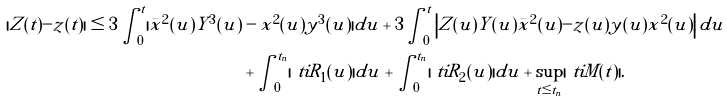Convert formula to latex. <formula><loc_0><loc_0><loc_500><loc_500>| Z ( t ) - z ( t ) | \leq 3 \int _ { 0 } ^ { t } | \bar { x } ^ { 2 } ( u ) Y ^ { 3 } ( u ) & - x ^ { 2 } ( u ) y ^ { 3 } ( u ) | d u + 3 \int _ { 0 } ^ { t } \left | Z ( u ) Y ( u ) \bar { x } ^ { 2 } ( u ) - z ( u ) y ( u ) x ^ { 2 } ( u ) \right | d u \\ & + \int _ { 0 } ^ { t _ { n } } | \ t i R _ { 1 } ( u ) | d u + \int _ { 0 } ^ { t _ { n } } | \ t i R _ { 2 } ( u ) | d u + \sup _ { t \leq t _ { n } } | \ t i M ( t ) | .</formula> 